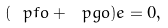Convert formula to latex. <formula><loc_0><loc_0><loc_500><loc_500>( \ p f o + \ p g o ) e = 0 ,</formula> 